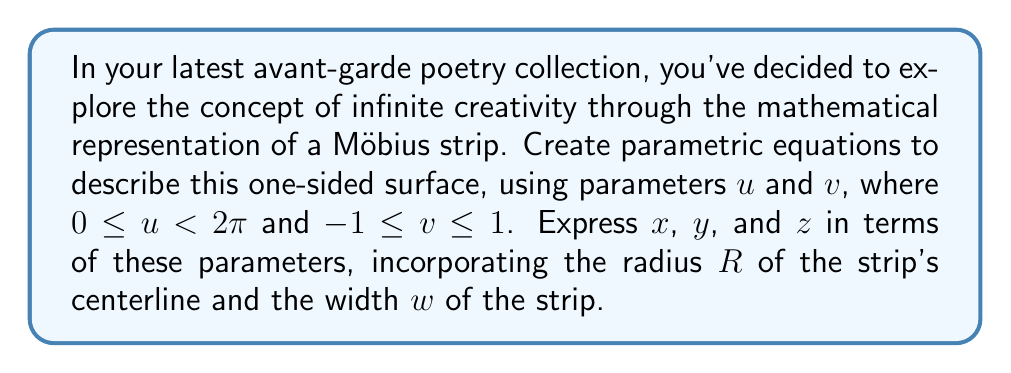Show me your answer to this math problem. To create parametric equations for a Möbius strip, we need to consider its unique properties:

1. It has only one side and one edge.
2. It is non-orientable.
3. It can be formed by taking a strip of paper, giving it a half-twist, and joining the ends.

Let's break down the construction:

1. Start with a circle in the xy-plane with radius $R$:
   $x = R \cos(u)$
   $y = R \sin(u)$

2. Add the width of the strip perpendicular to the circle, but with a twist:
   The twist is achieved by multiplying $v$ by $\cos(u/2)$ and $\sin(u/2)$:
   $x = R \cos(u) + v \cos(u/2)$
   $y = R \sin(u) + v \sin(u/2)$

3. To create the half-twist, we need to add a z-component that changes sign as u goes from 0 to 2π:
   $z = v \sin(u/2)$

4. Scale the width component by $w/2$ to get the full width:
   $x = R \cos(u) + \frac{w}{2}v \cos(u/2)$
   $y = R \sin(u) + \frac{w}{2}v \sin(u/2)$
   $z = \frac{w}{2}v \sin(u/2)$

These equations describe a Möbius strip with centerline radius $R$ and width $w$, parameterized by $u$ and $v$.
Answer: The parametric equations for a Möbius strip are:

$$\begin{align*}
x &= R \cos(u) + \frac{w}{2}v \cos(u/2) \\
y &= R \sin(u) + \frac{w}{2}v \sin(u/2) \\
z &= \frac{w}{2}v \sin(u/2)
\end{align*}$$

Where $0 \leq u < 2\pi$, $-1 \leq v \leq 1$, $R$ is the radius of the centerline, and $w$ is the width of the strip. 